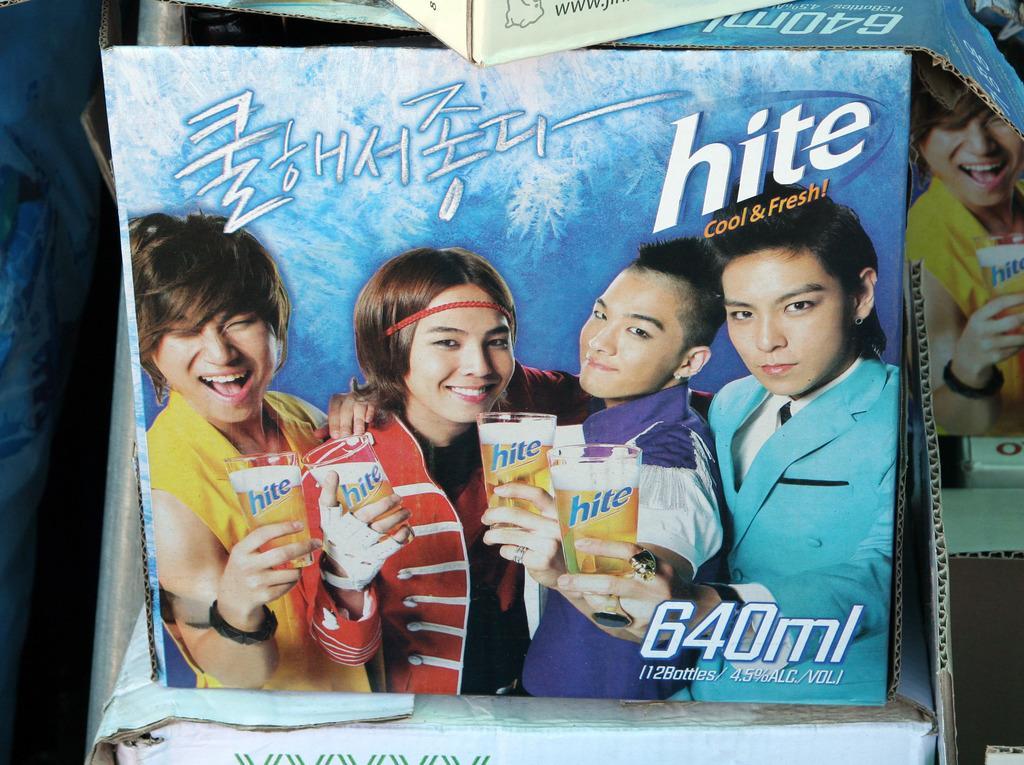How would you summarize this image in a sentence or two? In this image 4 person are standing by holding the beer glasses in their hands and smiling. 